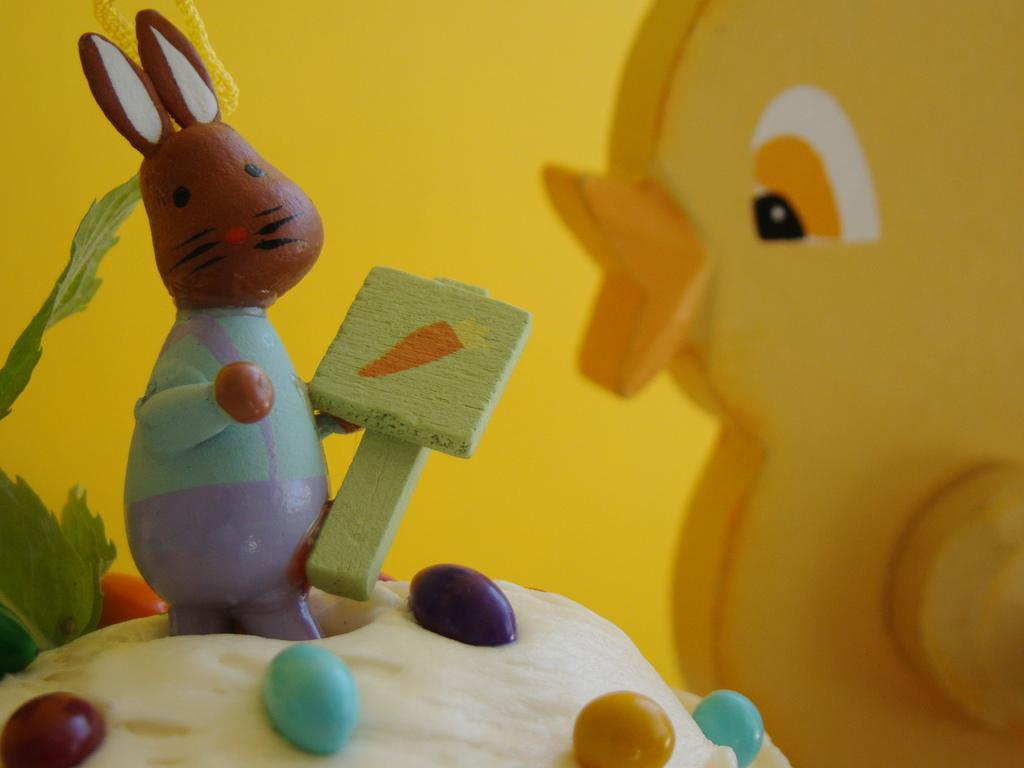What types of objects can be seen in the image? There are toys and candies in the image. Can you describe the toys in the image? Unfortunately, the specific types of toys cannot be determined from the provided facts. How many types of objects are present in the image? There are two types of objects present in the image: toys and candies. What type of cactus can be seen in the image? There is no cactus present in the image; it only features toys and candies. 